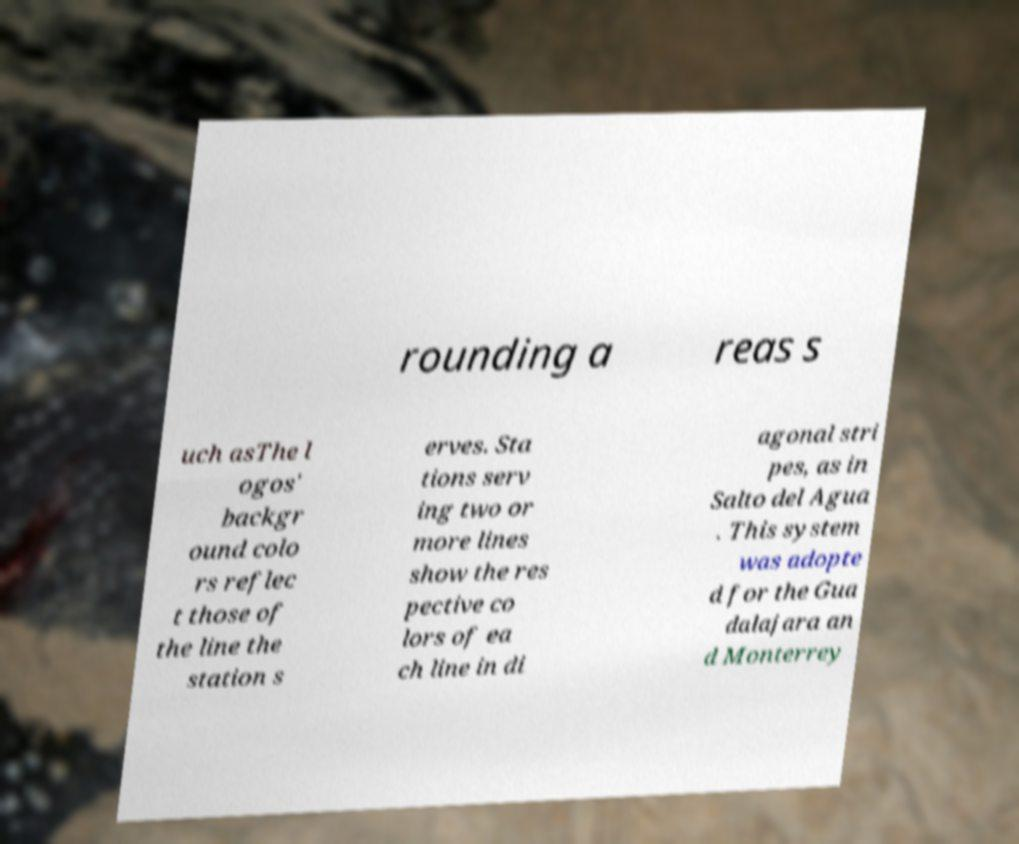There's text embedded in this image that I need extracted. Can you transcribe it verbatim? rounding a reas s uch asThe l ogos' backgr ound colo rs reflec t those of the line the station s erves. Sta tions serv ing two or more lines show the res pective co lors of ea ch line in di agonal stri pes, as in Salto del Agua . This system was adopte d for the Gua dalajara an d Monterrey 